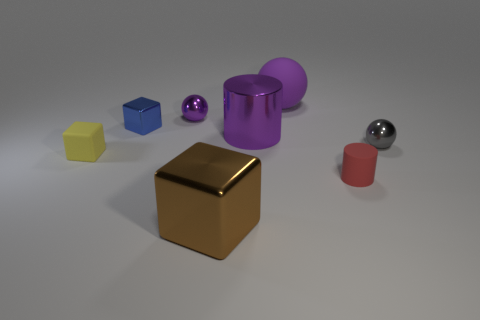Add 2 small metal objects. How many objects exist? 10 Subtract all cylinders. How many objects are left? 6 Subtract 1 brown cubes. How many objects are left? 7 Subtract all small cyan cylinders. Subtract all purple metallic spheres. How many objects are left? 7 Add 1 purple metallic cylinders. How many purple metallic cylinders are left? 2 Add 6 green cubes. How many green cubes exist? 6 